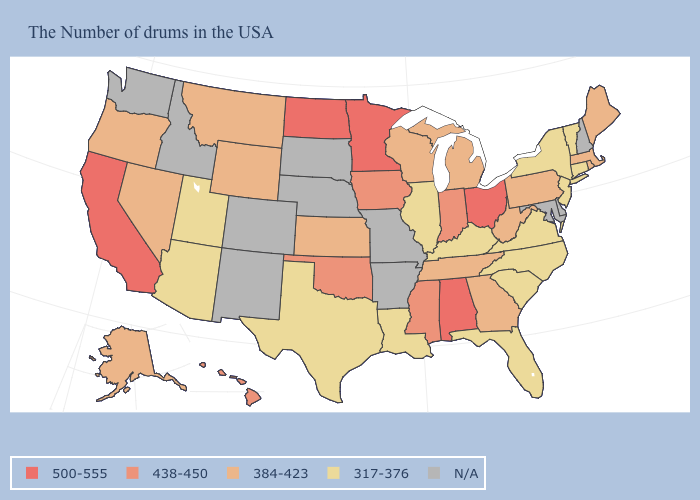What is the highest value in states that border Minnesota?
Give a very brief answer. 500-555. How many symbols are there in the legend?
Give a very brief answer. 5. What is the value of New Mexico?
Concise answer only. N/A. Which states have the highest value in the USA?
Answer briefly. Ohio, Alabama, Minnesota, North Dakota, California. What is the value of Oregon?
Keep it brief. 384-423. Is the legend a continuous bar?
Write a very short answer. No. What is the lowest value in the Northeast?
Be succinct. 317-376. Name the states that have a value in the range 500-555?
Concise answer only. Ohio, Alabama, Minnesota, North Dakota, California. Name the states that have a value in the range N/A?
Concise answer only. New Hampshire, Delaware, Maryland, Missouri, Arkansas, Nebraska, South Dakota, Colorado, New Mexico, Idaho, Washington. Name the states that have a value in the range 438-450?
Answer briefly. Indiana, Mississippi, Iowa, Oklahoma, Hawaii. What is the highest value in the West ?
Short answer required. 500-555. Does the map have missing data?
Keep it brief. Yes. Which states have the highest value in the USA?
Short answer required. Ohio, Alabama, Minnesota, North Dakota, California. Name the states that have a value in the range 384-423?
Give a very brief answer. Maine, Massachusetts, Rhode Island, Pennsylvania, West Virginia, Georgia, Michigan, Tennessee, Wisconsin, Kansas, Wyoming, Montana, Nevada, Oregon, Alaska. What is the value of Vermont?
Give a very brief answer. 317-376. 